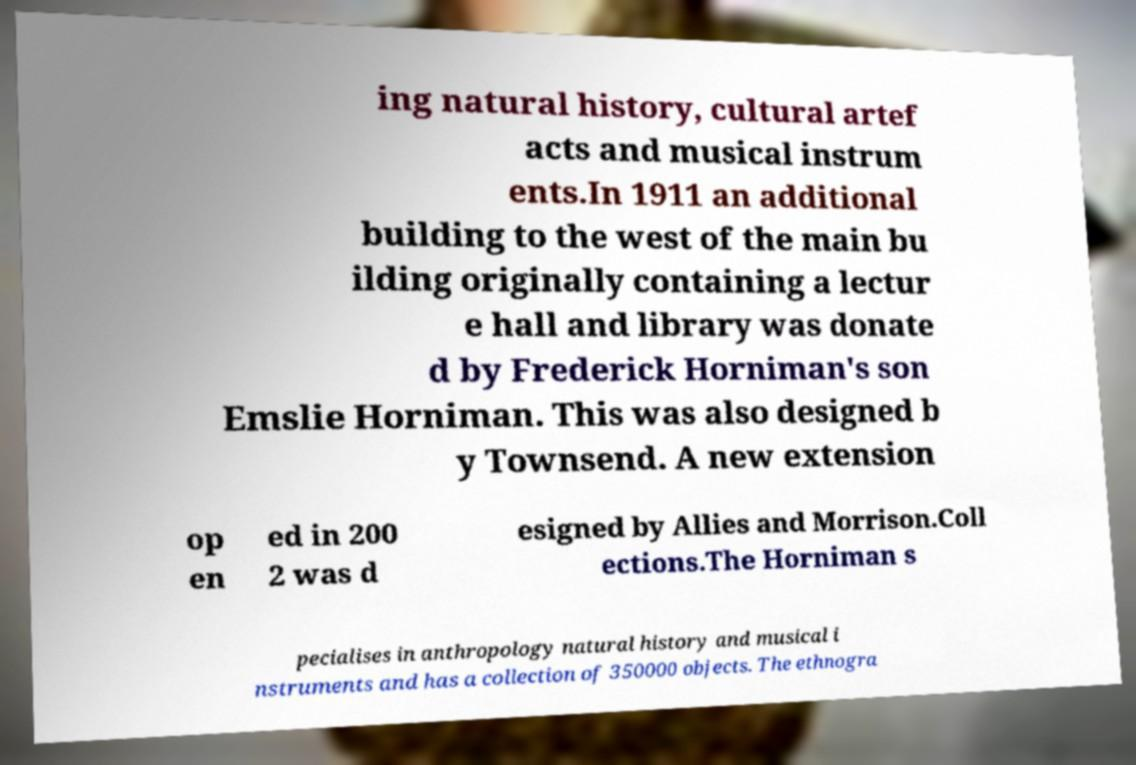There's text embedded in this image that I need extracted. Can you transcribe it verbatim? ing natural history, cultural artef acts and musical instrum ents.In 1911 an additional building to the west of the main bu ilding originally containing a lectur e hall and library was donate d by Frederick Horniman's son Emslie Horniman. This was also designed b y Townsend. A new extension op en ed in 200 2 was d esigned by Allies and Morrison.Coll ections.The Horniman s pecialises in anthropology natural history and musical i nstruments and has a collection of 350000 objects. The ethnogra 